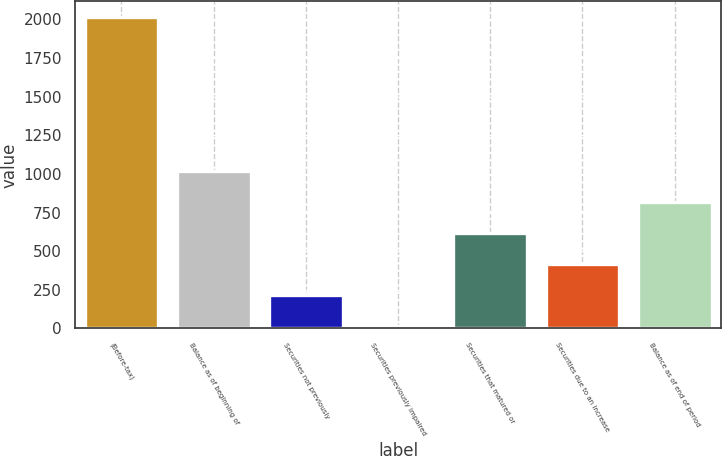Convert chart to OTSL. <chart><loc_0><loc_0><loc_500><loc_500><bar_chart><fcel>(Before-tax)<fcel>Balance as of beginning of<fcel>Securities not previously<fcel>Securities previously impaired<fcel>Securities that matured or<fcel>Securities due to an increase<fcel>Balance as of end of period<nl><fcel>2016<fcel>1017<fcel>217.8<fcel>18<fcel>617.4<fcel>417.6<fcel>817.2<nl></chart> 